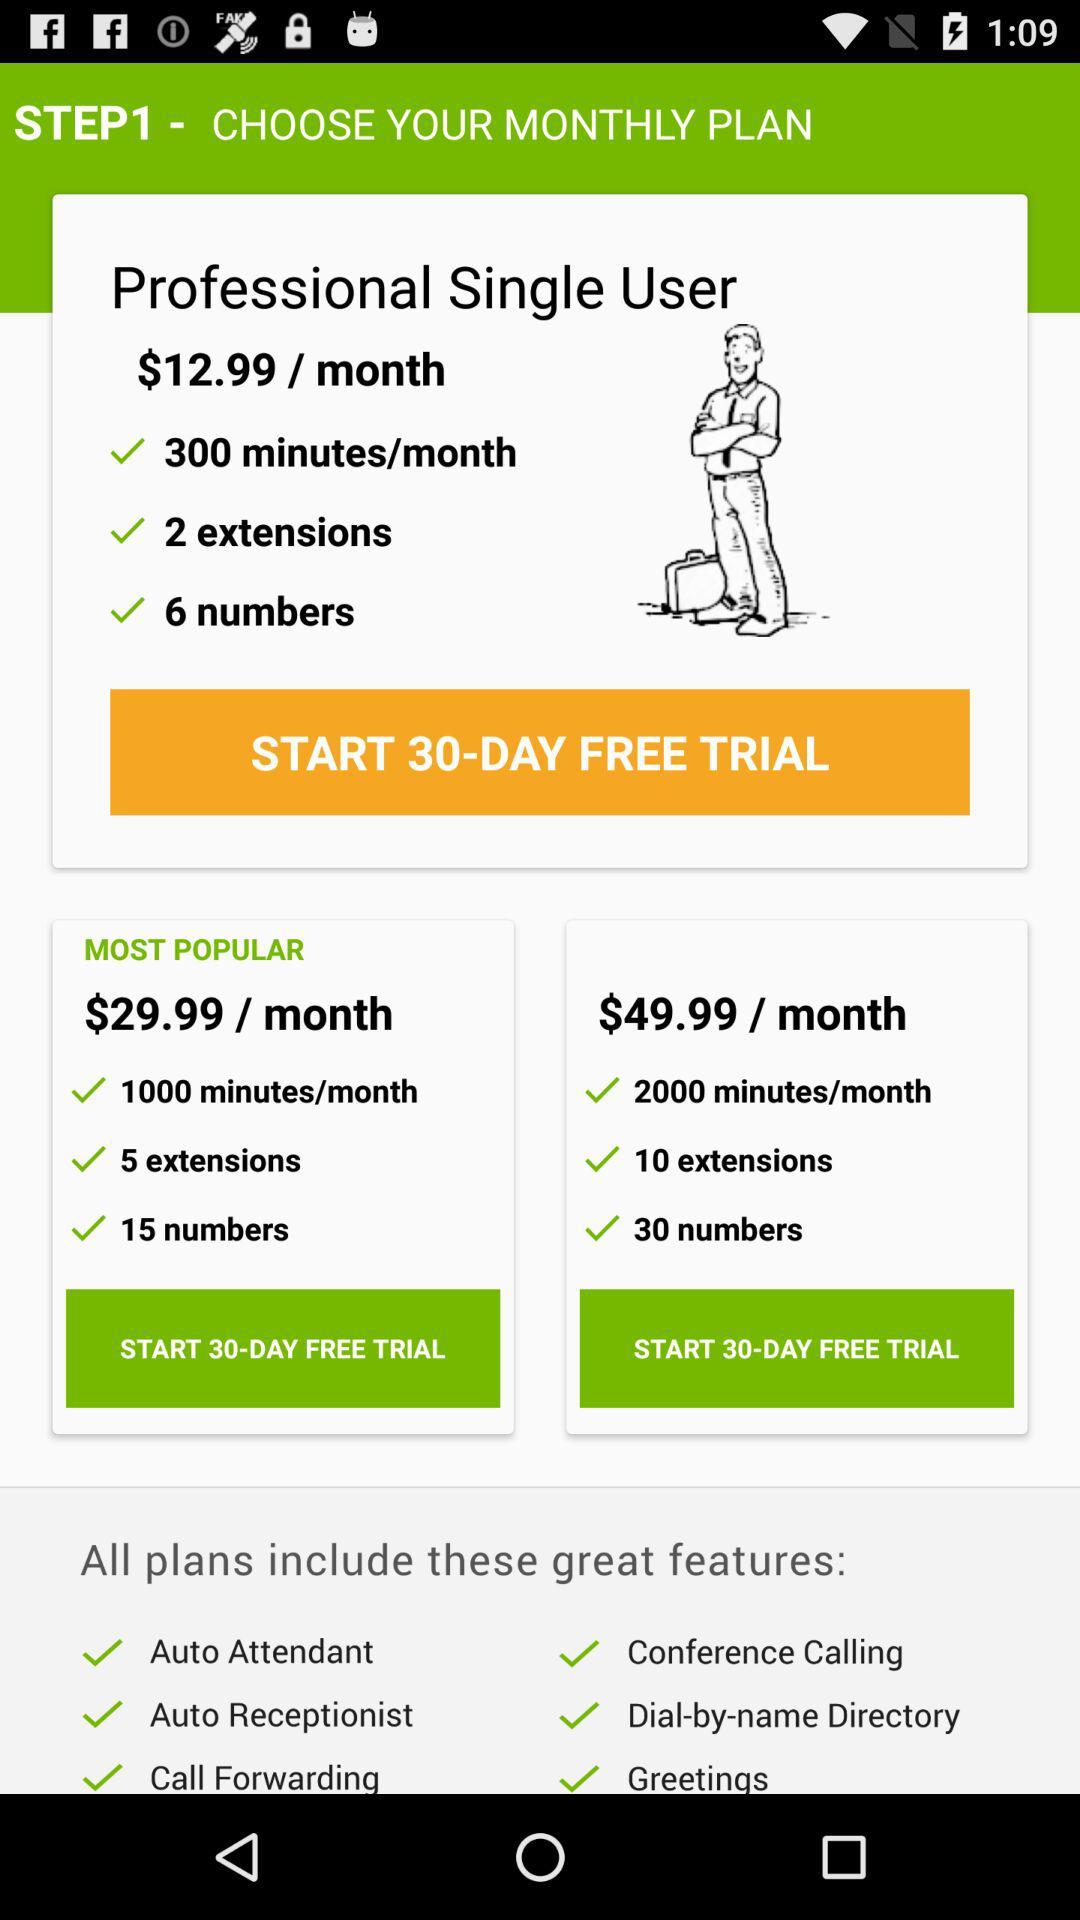How many more extensions are included in the $49.99 plan than the $29.99 plan?
Answer the question using a single word or phrase. 5 